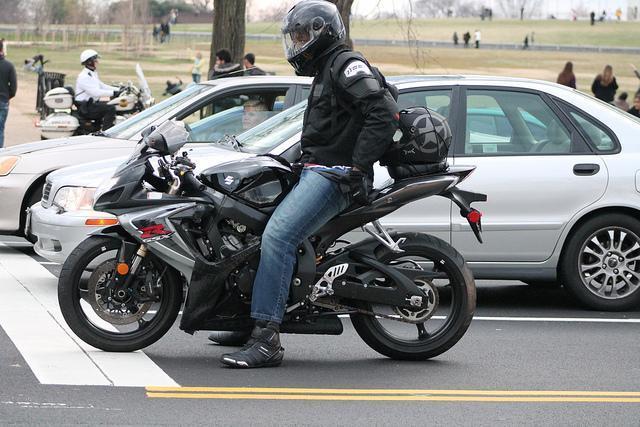How many bikes?
Give a very brief answer. 2. How many motorcycles are there?
Give a very brief answer. 2. How many cars are there?
Give a very brief answer. 2. How many people are in the photo?
Give a very brief answer. 3. 